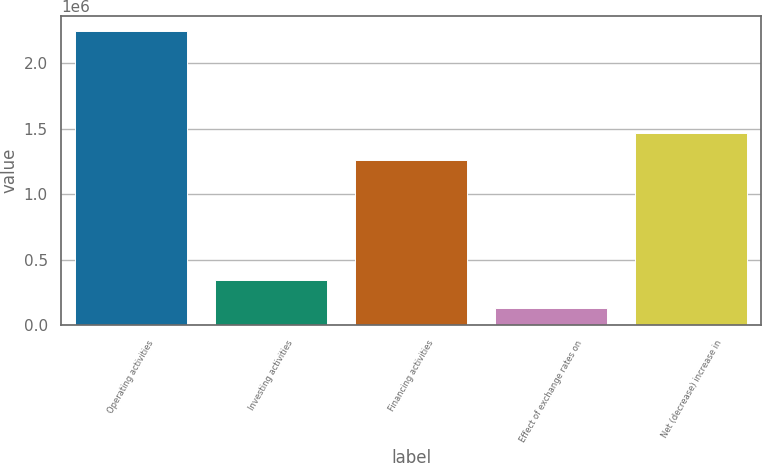Convert chart. <chart><loc_0><loc_0><loc_500><loc_500><bar_chart><fcel>Operating activities<fcel>Investing activities<fcel>Financing activities<fcel>Effect of exchange rates on<fcel>Net (decrease) increase in<nl><fcel>2.24779e+06<fcel>344709<fcel>1.26069e+06<fcel>133255<fcel>1.47214e+06<nl></chart> 